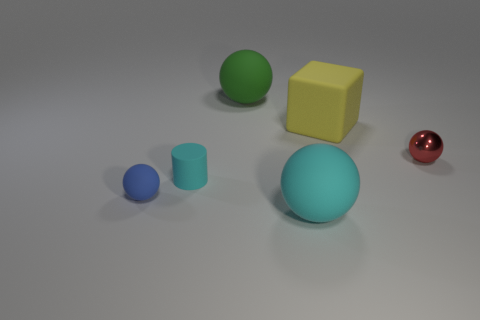Do the cyan object in front of the blue matte thing and the red sphere have the same material? Based on the visual attributes observable in the image, the cyan object and the red sphere do not appear to have the same material. The cyan object has a matte finish suggesting it scatters light diffusely, whereas the red sphere has a glossy surface that reflects light, indicating it is likely made of a different, more reflective material. 